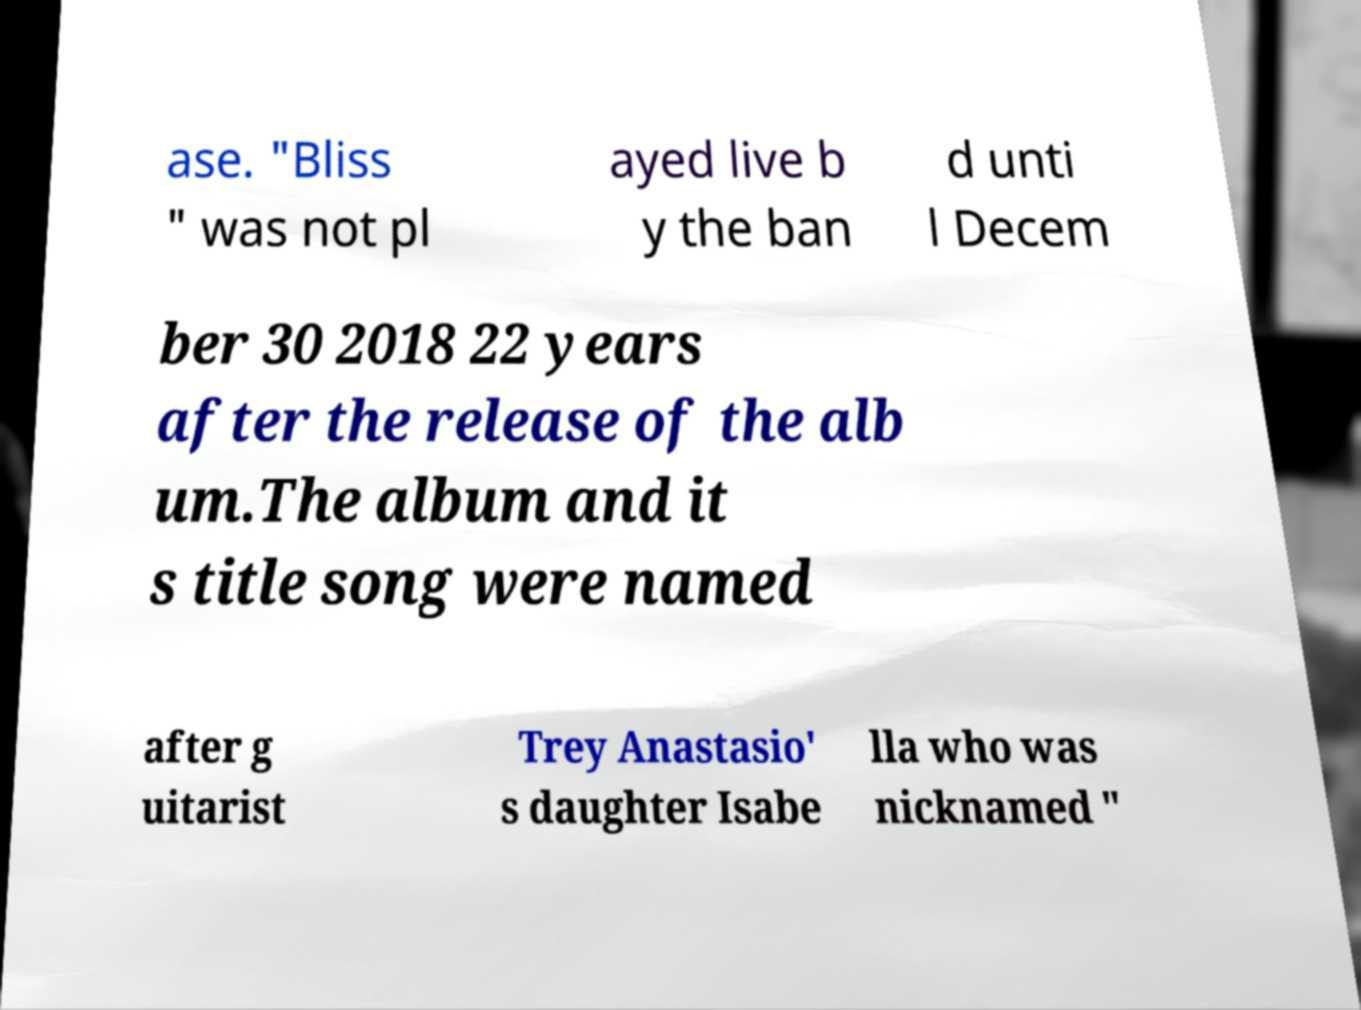Please identify and transcribe the text found in this image. ase. "Bliss " was not pl ayed live b y the ban d unti l Decem ber 30 2018 22 years after the release of the alb um.The album and it s title song were named after g uitarist Trey Anastasio' s daughter Isabe lla who was nicknamed " 